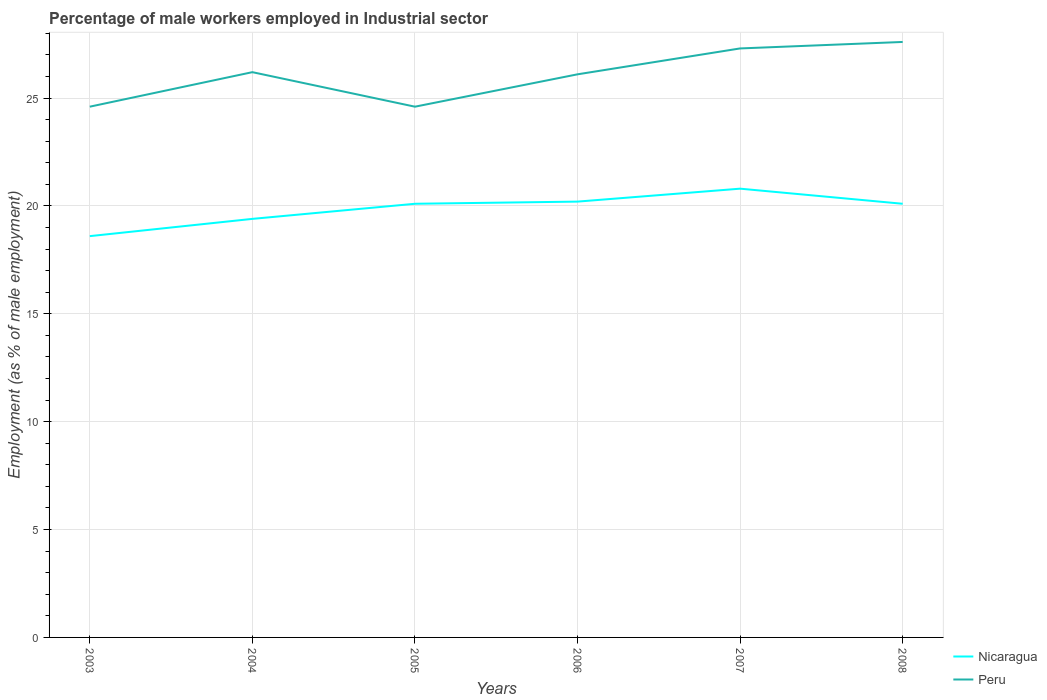How many different coloured lines are there?
Give a very brief answer. 2. Does the line corresponding to Peru intersect with the line corresponding to Nicaragua?
Your answer should be compact. No. Is the number of lines equal to the number of legend labels?
Provide a short and direct response. Yes. Across all years, what is the maximum percentage of male workers employed in Industrial sector in Nicaragua?
Your answer should be very brief. 18.6. In which year was the percentage of male workers employed in Industrial sector in Nicaragua maximum?
Offer a very short reply. 2003. What is the total percentage of male workers employed in Industrial sector in Nicaragua in the graph?
Give a very brief answer. -0.1. What is the difference between the highest and the lowest percentage of male workers employed in Industrial sector in Peru?
Provide a short and direct response. 4. Is the percentage of male workers employed in Industrial sector in Peru strictly greater than the percentage of male workers employed in Industrial sector in Nicaragua over the years?
Provide a short and direct response. No. How many years are there in the graph?
Offer a very short reply. 6. Does the graph contain any zero values?
Your answer should be very brief. No. Where does the legend appear in the graph?
Give a very brief answer. Bottom right. What is the title of the graph?
Provide a succinct answer. Percentage of male workers employed in Industrial sector. What is the label or title of the Y-axis?
Your answer should be very brief. Employment (as % of male employment). What is the Employment (as % of male employment) of Nicaragua in 2003?
Your response must be concise. 18.6. What is the Employment (as % of male employment) of Peru in 2003?
Provide a succinct answer. 24.6. What is the Employment (as % of male employment) in Nicaragua in 2004?
Your answer should be compact. 19.4. What is the Employment (as % of male employment) in Peru in 2004?
Your answer should be very brief. 26.2. What is the Employment (as % of male employment) of Nicaragua in 2005?
Ensure brevity in your answer.  20.1. What is the Employment (as % of male employment) of Peru in 2005?
Your answer should be compact. 24.6. What is the Employment (as % of male employment) in Nicaragua in 2006?
Keep it short and to the point. 20.2. What is the Employment (as % of male employment) of Peru in 2006?
Ensure brevity in your answer.  26.1. What is the Employment (as % of male employment) of Nicaragua in 2007?
Make the answer very short. 20.8. What is the Employment (as % of male employment) in Peru in 2007?
Give a very brief answer. 27.3. What is the Employment (as % of male employment) in Nicaragua in 2008?
Provide a succinct answer. 20.1. What is the Employment (as % of male employment) in Peru in 2008?
Offer a terse response. 27.6. Across all years, what is the maximum Employment (as % of male employment) of Nicaragua?
Offer a very short reply. 20.8. Across all years, what is the maximum Employment (as % of male employment) in Peru?
Your response must be concise. 27.6. Across all years, what is the minimum Employment (as % of male employment) of Nicaragua?
Provide a succinct answer. 18.6. Across all years, what is the minimum Employment (as % of male employment) of Peru?
Give a very brief answer. 24.6. What is the total Employment (as % of male employment) in Nicaragua in the graph?
Offer a terse response. 119.2. What is the total Employment (as % of male employment) of Peru in the graph?
Make the answer very short. 156.4. What is the difference between the Employment (as % of male employment) of Peru in 2003 and that in 2004?
Provide a short and direct response. -1.6. What is the difference between the Employment (as % of male employment) of Nicaragua in 2003 and that in 2005?
Your answer should be compact. -1.5. What is the difference between the Employment (as % of male employment) in Peru in 2003 and that in 2006?
Your answer should be very brief. -1.5. What is the difference between the Employment (as % of male employment) in Peru in 2003 and that in 2007?
Your answer should be very brief. -2.7. What is the difference between the Employment (as % of male employment) in Nicaragua in 2004 and that in 2005?
Make the answer very short. -0.7. What is the difference between the Employment (as % of male employment) in Peru in 2004 and that in 2005?
Your answer should be compact. 1.6. What is the difference between the Employment (as % of male employment) in Nicaragua in 2004 and that in 2006?
Offer a terse response. -0.8. What is the difference between the Employment (as % of male employment) of Peru in 2004 and that in 2006?
Keep it short and to the point. 0.1. What is the difference between the Employment (as % of male employment) of Peru in 2004 and that in 2008?
Your response must be concise. -1.4. What is the difference between the Employment (as % of male employment) of Peru in 2005 and that in 2007?
Your response must be concise. -2.7. What is the difference between the Employment (as % of male employment) of Nicaragua in 2005 and that in 2008?
Provide a short and direct response. 0. What is the difference between the Employment (as % of male employment) of Nicaragua in 2006 and that in 2007?
Offer a very short reply. -0.6. What is the difference between the Employment (as % of male employment) of Peru in 2006 and that in 2007?
Your answer should be very brief. -1.2. What is the difference between the Employment (as % of male employment) of Nicaragua in 2006 and that in 2008?
Provide a short and direct response. 0.1. What is the difference between the Employment (as % of male employment) in Nicaragua in 2007 and that in 2008?
Offer a terse response. 0.7. What is the difference between the Employment (as % of male employment) in Nicaragua in 2003 and the Employment (as % of male employment) in Peru in 2005?
Make the answer very short. -6. What is the difference between the Employment (as % of male employment) in Nicaragua in 2003 and the Employment (as % of male employment) in Peru in 2007?
Provide a short and direct response. -8.7. What is the difference between the Employment (as % of male employment) of Nicaragua in 2004 and the Employment (as % of male employment) of Peru in 2005?
Offer a very short reply. -5.2. What is the difference between the Employment (as % of male employment) in Nicaragua in 2005 and the Employment (as % of male employment) in Peru in 2006?
Give a very brief answer. -6. What is the difference between the Employment (as % of male employment) of Nicaragua in 2006 and the Employment (as % of male employment) of Peru in 2007?
Provide a succinct answer. -7.1. What is the average Employment (as % of male employment) in Nicaragua per year?
Provide a short and direct response. 19.87. What is the average Employment (as % of male employment) in Peru per year?
Offer a terse response. 26.07. In the year 2005, what is the difference between the Employment (as % of male employment) in Nicaragua and Employment (as % of male employment) in Peru?
Offer a very short reply. -4.5. In the year 2007, what is the difference between the Employment (as % of male employment) in Nicaragua and Employment (as % of male employment) in Peru?
Your response must be concise. -6.5. What is the ratio of the Employment (as % of male employment) in Nicaragua in 2003 to that in 2004?
Ensure brevity in your answer.  0.96. What is the ratio of the Employment (as % of male employment) of Peru in 2003 to that in 2004?
Offer a terse response. 0.94. What is the ratio of the Employment (as % of male employment) in Nicaragua in 2003 to that in 2005?
Provide a short and direct response. 0.93. What is the ratio of the Employment (as % of male employment) of Peru in 2003 to that in 2005?
Give a very brief answer. 1. What is the ratio of the Employment (as % of male employment) in Nicaragua in 2003 to that in 2006?
Your answer should be very brief. 0.92. What is the ratio of the Employment (as % of male employment) of Peru in 2003 to that in 2006?
Provide a short and direct response. 0.94. What is the ratio of the Employment (as % of male employment) in Nicaragua in 2003 to that in 2007?
Make the answer very short. 0.89. What is the ratio of the Employment (as % of male employment) of Peru in 2003 to that in 2007?
Offer a terse response. 0.9. What is the ratio of the Employment (as % of male employment) in Nicaragua in 2003 to that in 2008?
Your response must be concise. 0.93. What is the ratio of the Employment (as % of male employment) of Peru in 2003 to that in 2008?
Provide a short and direct response. 0.89. What is the ratio of the Employment (as % of male employment) in Nicaragua in 2004 to that in 2005?
Your answer should be compact. 0.97. What is the ratio of the Employment (as % of male employment) in Peru in 2004 to that in 2005?
Provide a succinct answer. 1.06. What is the ratio of the Employment (as % of male employment) in Nicaragua in 2004 to that in 2006?
Provide a short and direct response. 0.96. What is the ratio of the Employment (as % of male employment) of Peru in 2004 to that in 2006?
Make the answer very short. 1. What is the ratio of the Employment (as % of male employment) in Nicaragua in 2004 to that in 2007?
Your answer should be very brief. 0.93. What is the ratio of the Employment (as % of male employment) of Peru in 2004 to that in 2007?
Your answer should be very brief. 0.96. What is the ratio of the Employment (as % of male employment) in Nicaragua in 2004 to that in 2008?
Ensure brevity in your answer.  0.97. What is the ratio of the Employment (as % of male employment) in Peru in 2004 to that in 2008?
Ensure brevity in your answer.  0.95. What is the ratio of the Employment (as % of male employment) of Peru in 2005 to that in 2006?
Provide a succinct answer. 0.94. What is the ratio of the Employment (as % of male employment) of Nicaragua in 2005 to that in 2007?
Give a very brief answer. 0.97. What is the ratio of the Employment (as % of male employment) in Peru in 2005 to that in 2007?
Your answer should be compact. 0.9. What is the ratio of the Employment (as % of male employment) of Peru in 2005 to that in 2008?
Make the answer very short. 0.89. What is the ratio of the Employment (as % of male employment) in Nicaragua in 2006 to that in 2007?
Your answer should be compact. 0.97. What is the ratio of the Employment (as % of male employment) in Peru in 2006 to that in 2007?
Your answer should be very brief. 0.96. What is the ratio of the Employment (as % of male employment) in Nicaragua in 2006 to that in 2008?
Give a very brief answer. 1. What is the ratio of the Employment (as % of male employment) of Peru in 2006 to that in 2008?
Ensure brevity in your answer.  0.95. What is the ratio of the Employment (as % of male employment) of Nicaragua in 2007 to that in 2008?
Your response must be concise. 1.03. What is the ratio of the Employment (as % of male employment) of Peru in 2007 to that in 2008?
Ensure brevity in your answer.  0.99. What is the difference between the highest and the second highest Employment (as % of male employment) in Peru?
Your response must be concise. 0.3. What is the difference between the highest and the lowest Employment (as % of male employment) of Peru?
Make the answer very short. 3. 